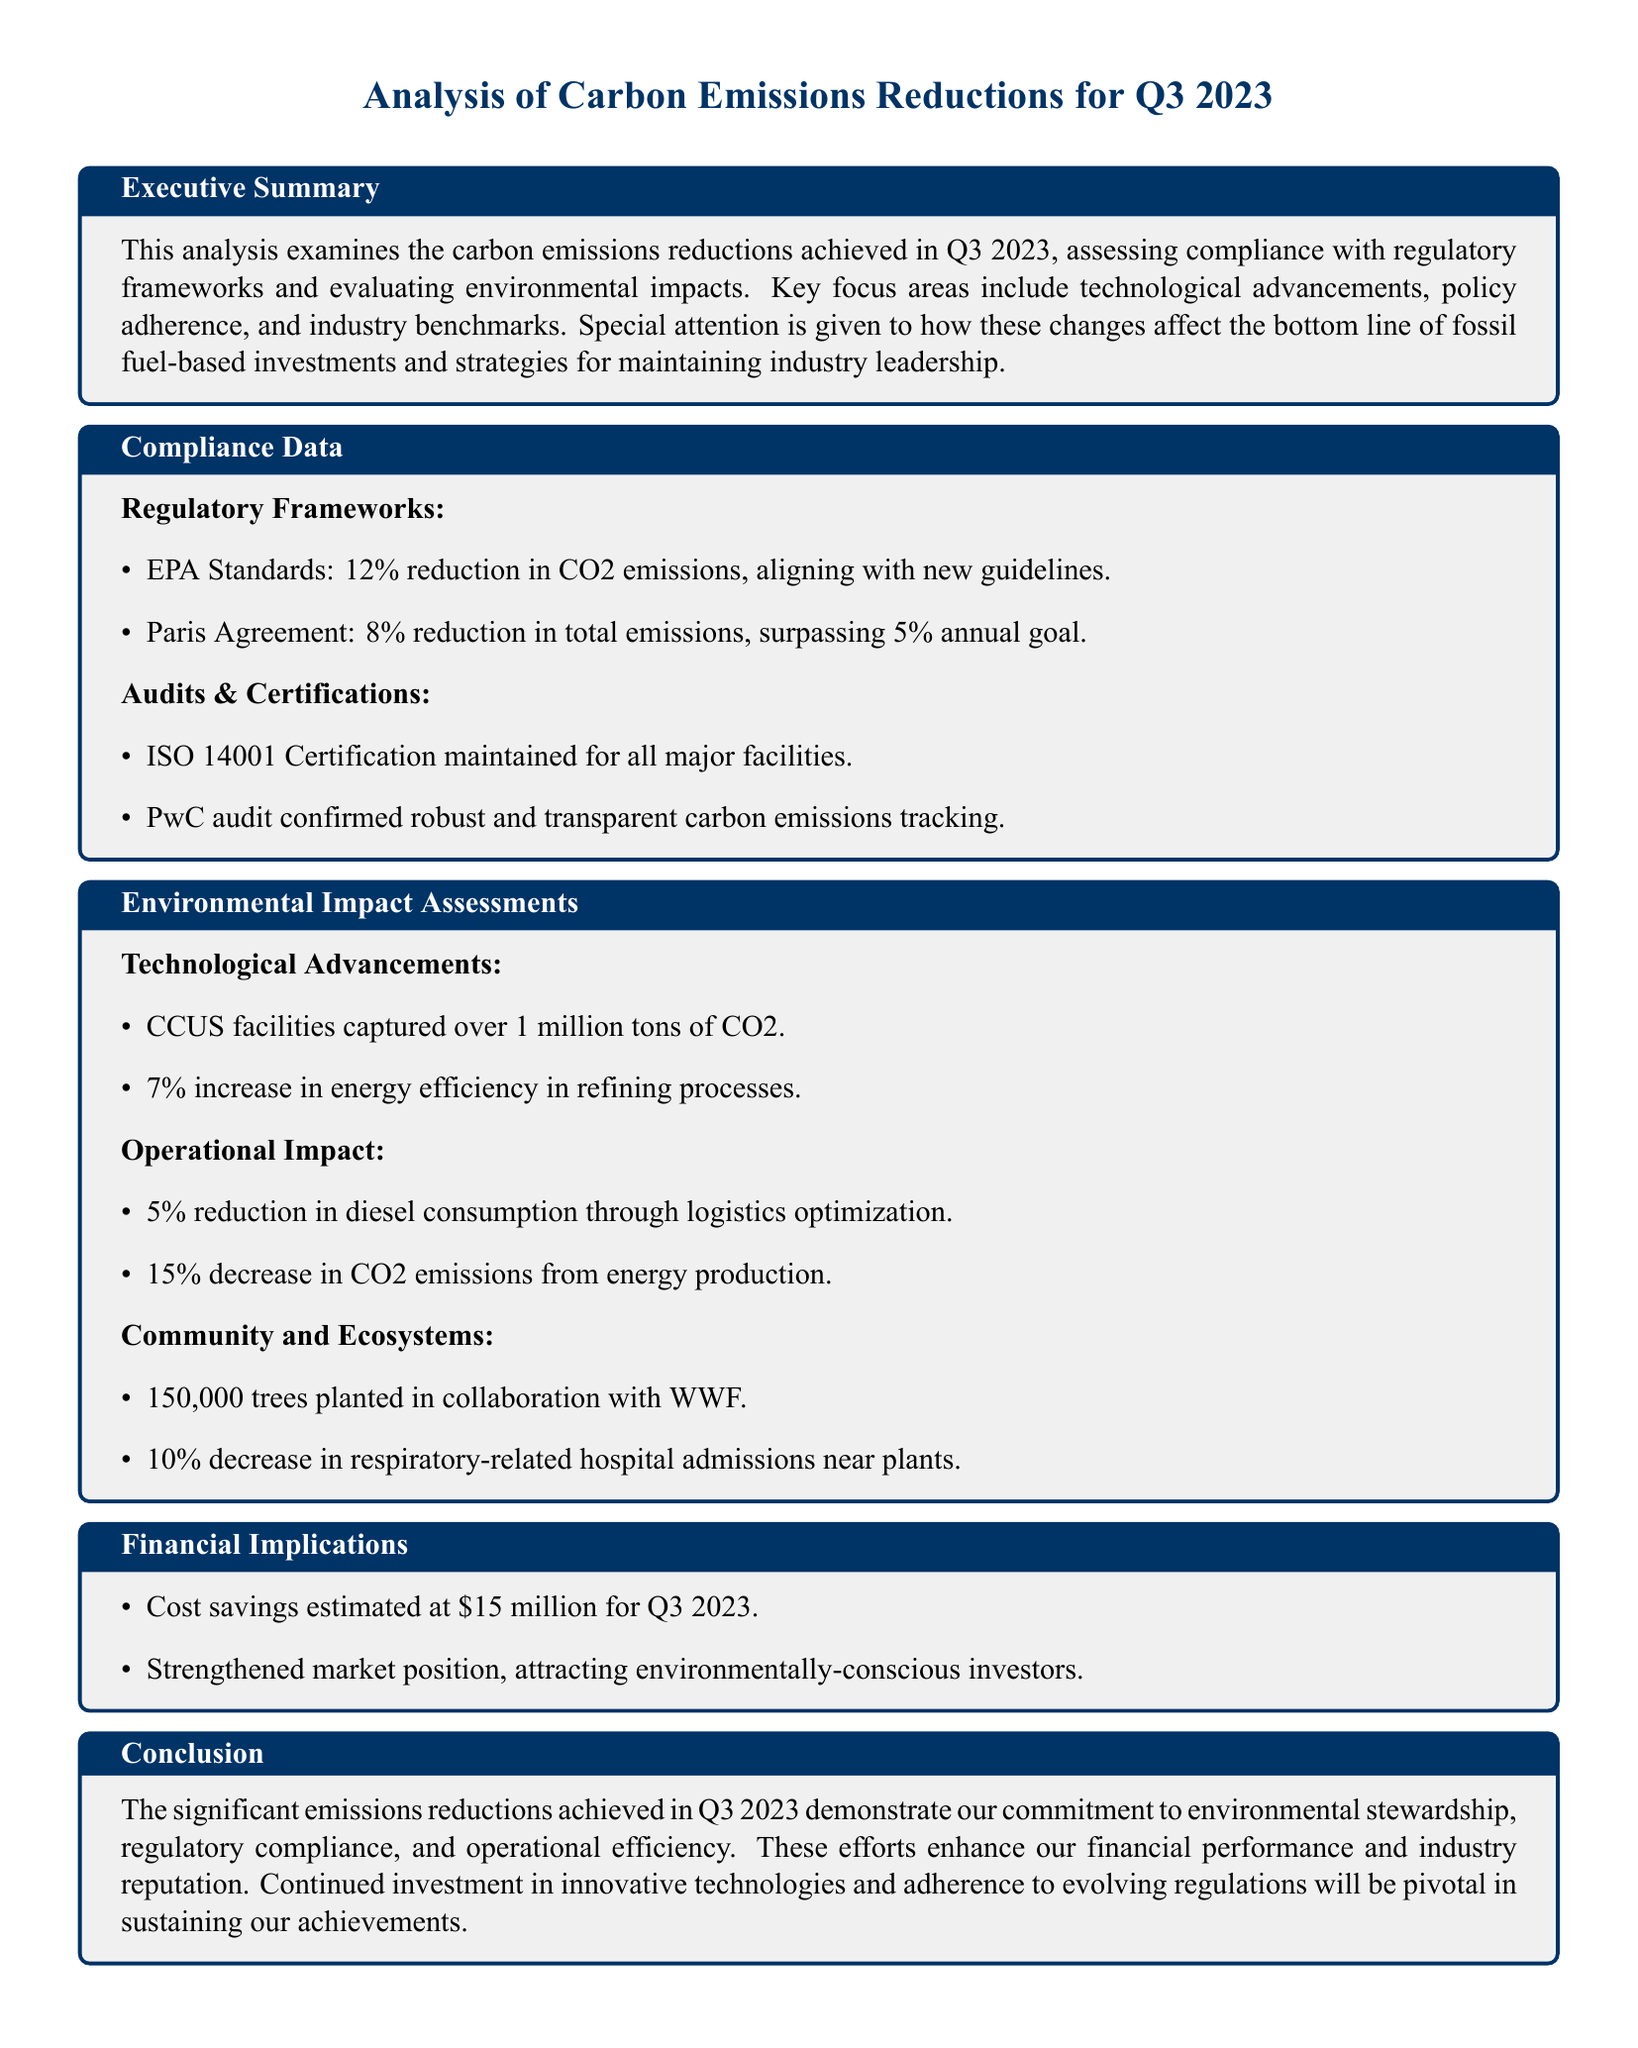What was the percentage reduction in CO2 emissions as per EPA Standards? The document states that there was a 12% reduction in CO2 emissions, aligning with new guidelines.
Answer: 12% What is the cost savings estimate for Q3 2023? The cost savings for Q3 2023 are documented as being estimated at $15 million.
Answer: $15 million How many tons of CO2 were captured by CCUS facilities? The analysis mentions that CCUS facilities captured over 1 million tons of CO2.
Answer: over 1 million tons What is the reduction in diesel consumption through logistics optimization? The document indicates a 5% reduction in diesel consumption due to logistics optimization.
Answer: 5% What was the increase in energy efficiency in refining processes? The increase in energy efficiency in refining processes is stated as 7%.
Answer: 7% Which certification was maintained for all major facilities? The document specifies that ISO 14001 Certification was maintained for all major facilities.
Answer: ISO 14001 Certification How many trees were planted in collaboration with WWF? The analysis reports that 150,000 trees were planted in collaboration with WWF.
Answer: 150,000 trees What was the decrease in respiratory-related hospital admissions near plants? The document notes a 10% decrease in respiratory-related hospital admissions near plants.
Answer: 10% What was the percentage reduction in total emissions according to the Paris Agreement? According to the document, a reduction of 8% in total emissions was achieved, surpassing the 5% annual goal.
Answer: 8% 